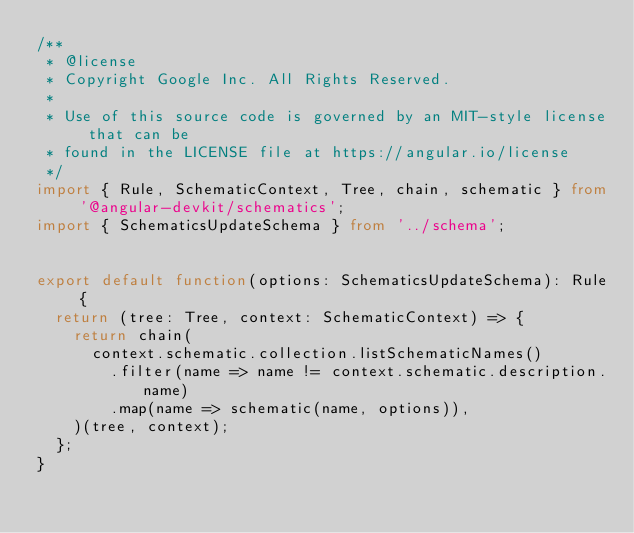Convert code to text. <code><loc_0><loc_0><loc_500><loc_500><_TypeScript_>/**
 * @license
 * Copyright Google Inc. All Rights Reserved.
 *
 * Use of this source code is governed by an MIT-style license that can be
 * found in the LICENSE file at https://angular.io/license
 */
import { Rule, SchematicContext, Tree, chain, schematic } from '@angular-devkit/schematics';
import { SchematicsUpdateSchema } from '../schema';


export default function(options: SchematicsUpdateSchema): Rule {
  return (tree: Tree, context: SchematicContext) => {
    return chain(
      context.schematic.collection.listSchematicNames()
        .filter(name => name != context.schematic.description.name)
        .map(name => schematic(name, options)),
    )(tree, context);
  };
}
</code> 